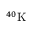Convert formula to latex. <formula><loc_0><loc_0><loc_500><loc_500>^ { 4 0 } K</formula> 